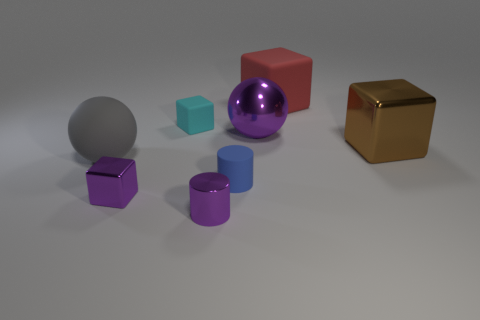The thing that is both behind the small blue rubber object and in front of the brown cube is made of what material?
Provide a short and direct response. Rubber. Does the brown thing have the same shape as the large object left of the small blue matte cylinder?
Keep it short and to the point. No. What material is the purple object in front of the metallic cube that is to the left of the big matte thing right of the small purple cube made of?
Give a very brief answer. Metal. What number of other things are the same size as the brown thing?
Provide a succinct answer. 3. Do the matte cylinder and the metallic sphere have the same color?
Offer a very short reply. No. There is a tiny matte thing that is behind the sphere that is on the right side of the big gray rubber ball; what number of large gray matte objects are right of it?
Provide a succinct answer. 0. What material is the big ball that is to the right of the block that is in front of the brown shiny thing?
Offer a terse response. Metal. Is there a gray matte thing that has the same shape as the large purple shiny object?
Provide a short and direct response. Yes. What is the color of the other ball that is the same size as the purple sphere?
Provide a succinct answer. Gray. How many objects are either tiny matte things that are in front of the brown cube or cubes that are in front of the gray matte object?
Offer a very short reply. 2. 